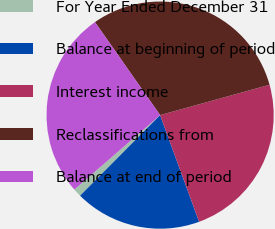Convert chart. <chart><loc_0><loc_0><loc_500><loc_500><pie_chart><fcel>For Year Ended December 31<fcel>Balance at beginning of period<fcel>Interest income<fcel>Reclassifications from<fcel>Balance at end of period<nl><fcel>1.18%<fcel>18.02%<fcel>23.73%<fcel>30.42%<fcel>26.65%<nl></chart> 